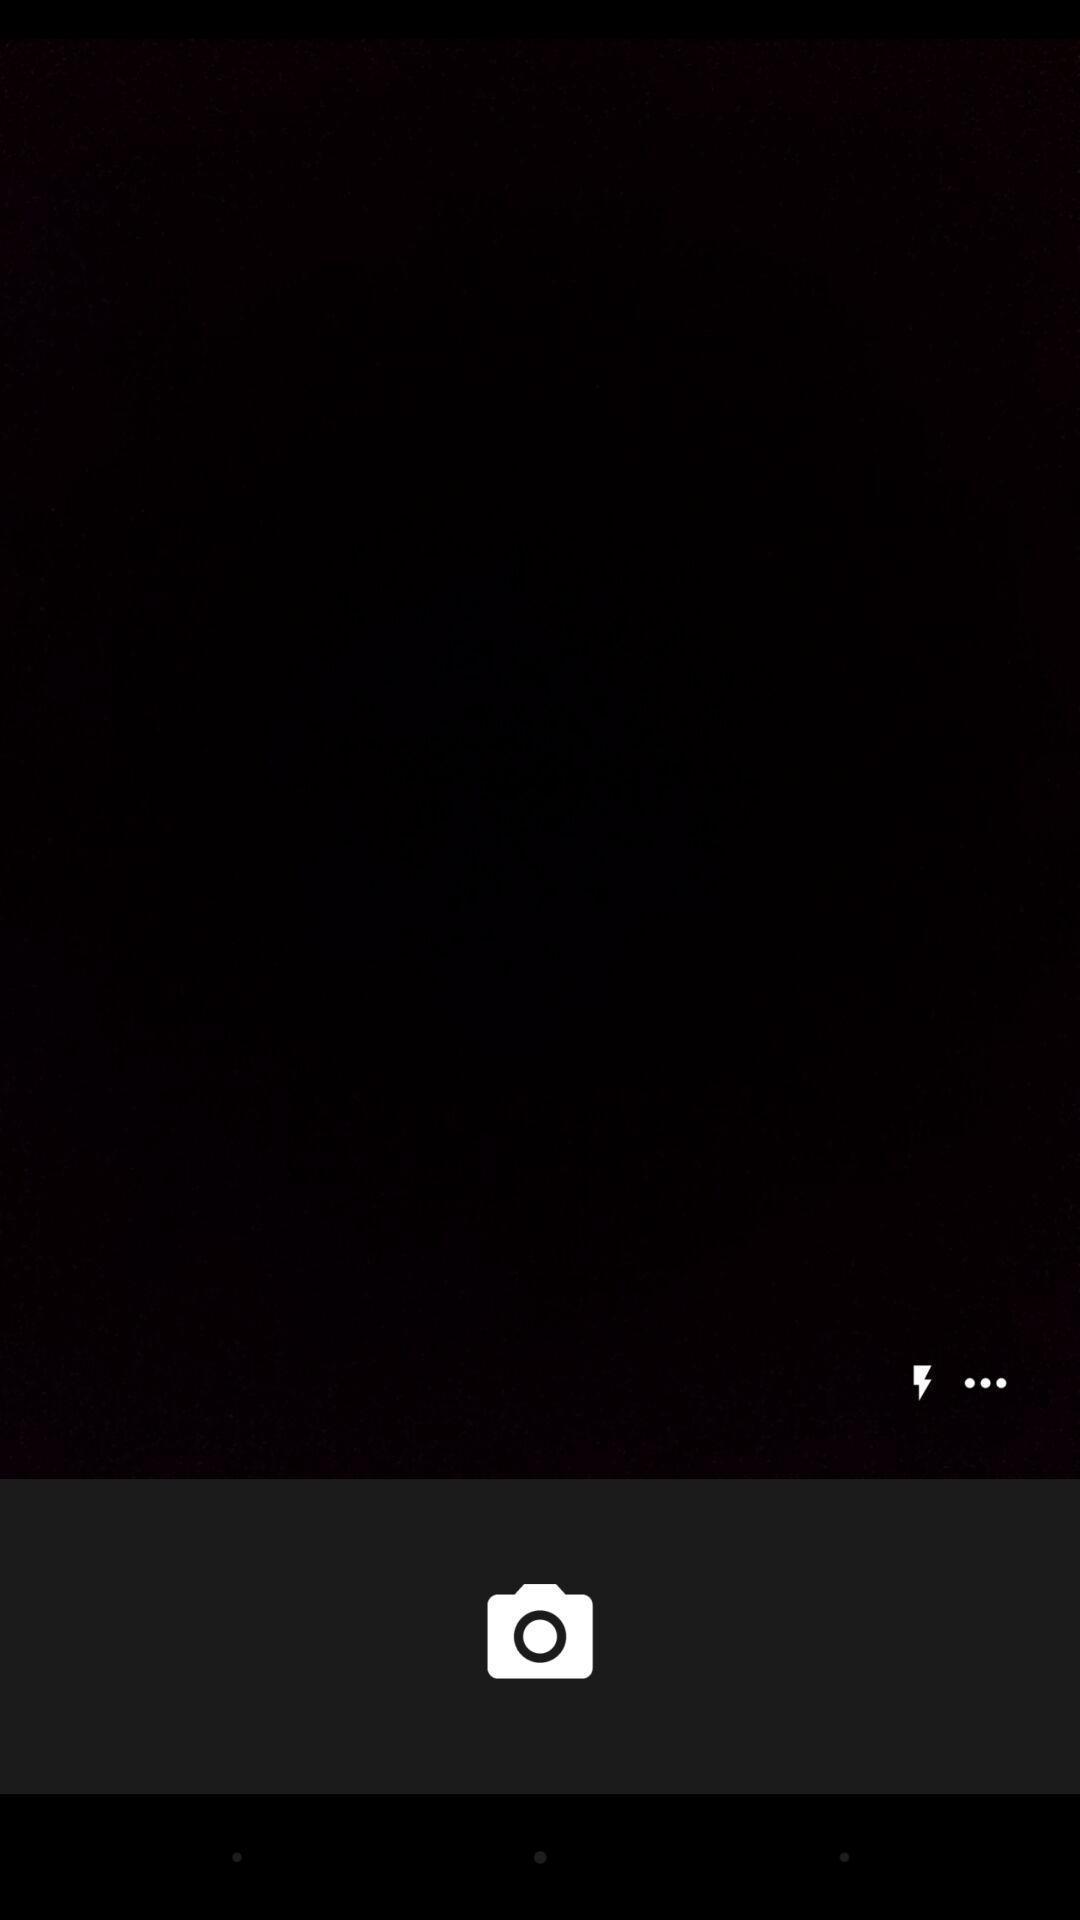Describe the visual elements of this screenshot. Page showing camera interface. 